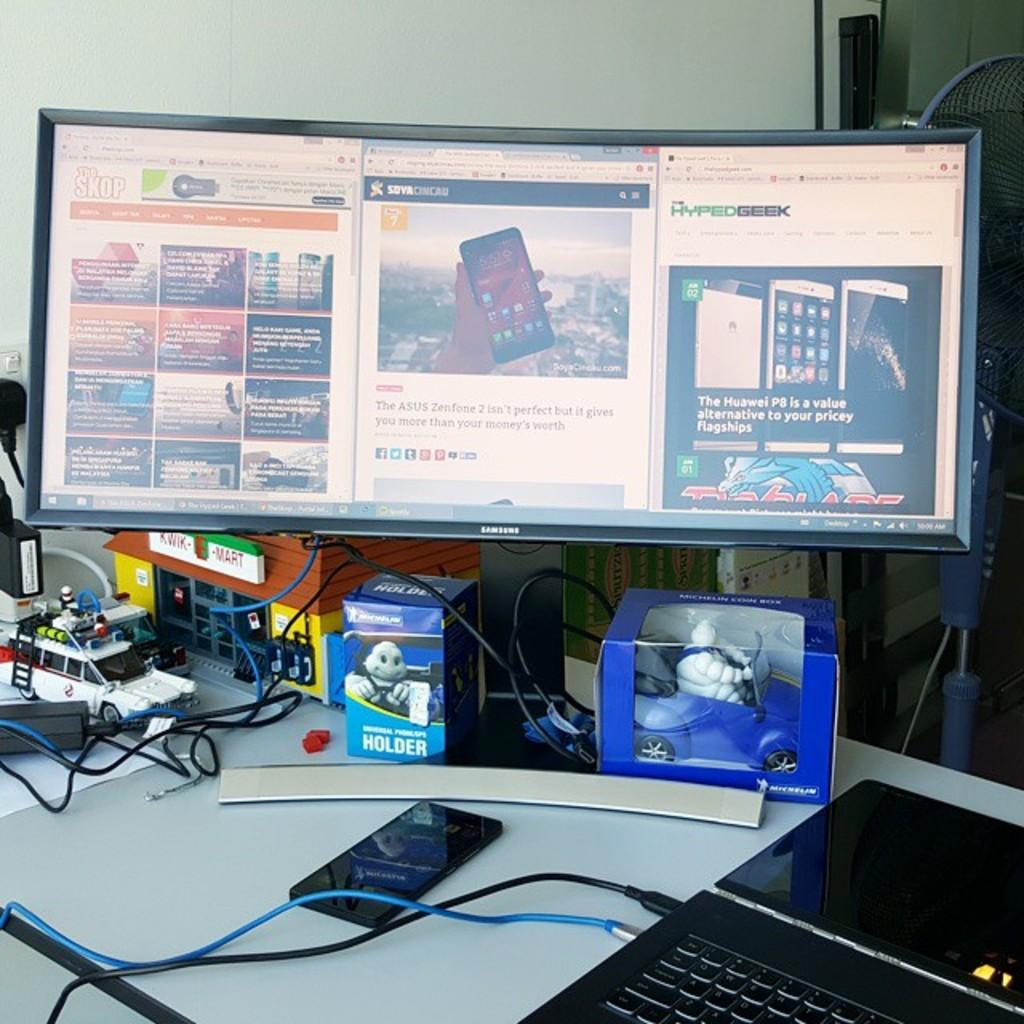What electronic devices can be seen in the image? There is a computer, a laptop, and a mobile phone in the image. What type of toys are present in the image? There are car toys in the image. What connects the devices in the image? Cables are present in the image. Where are the objects located in the image? The objects are on a table. What appliance can be seen in the top right side of the image? There is a fan on the top right side of the image. What type of wax can be seen melting in the image? There is no wax present in the image; it features electronic devices, car toys, cables, and a fan. 